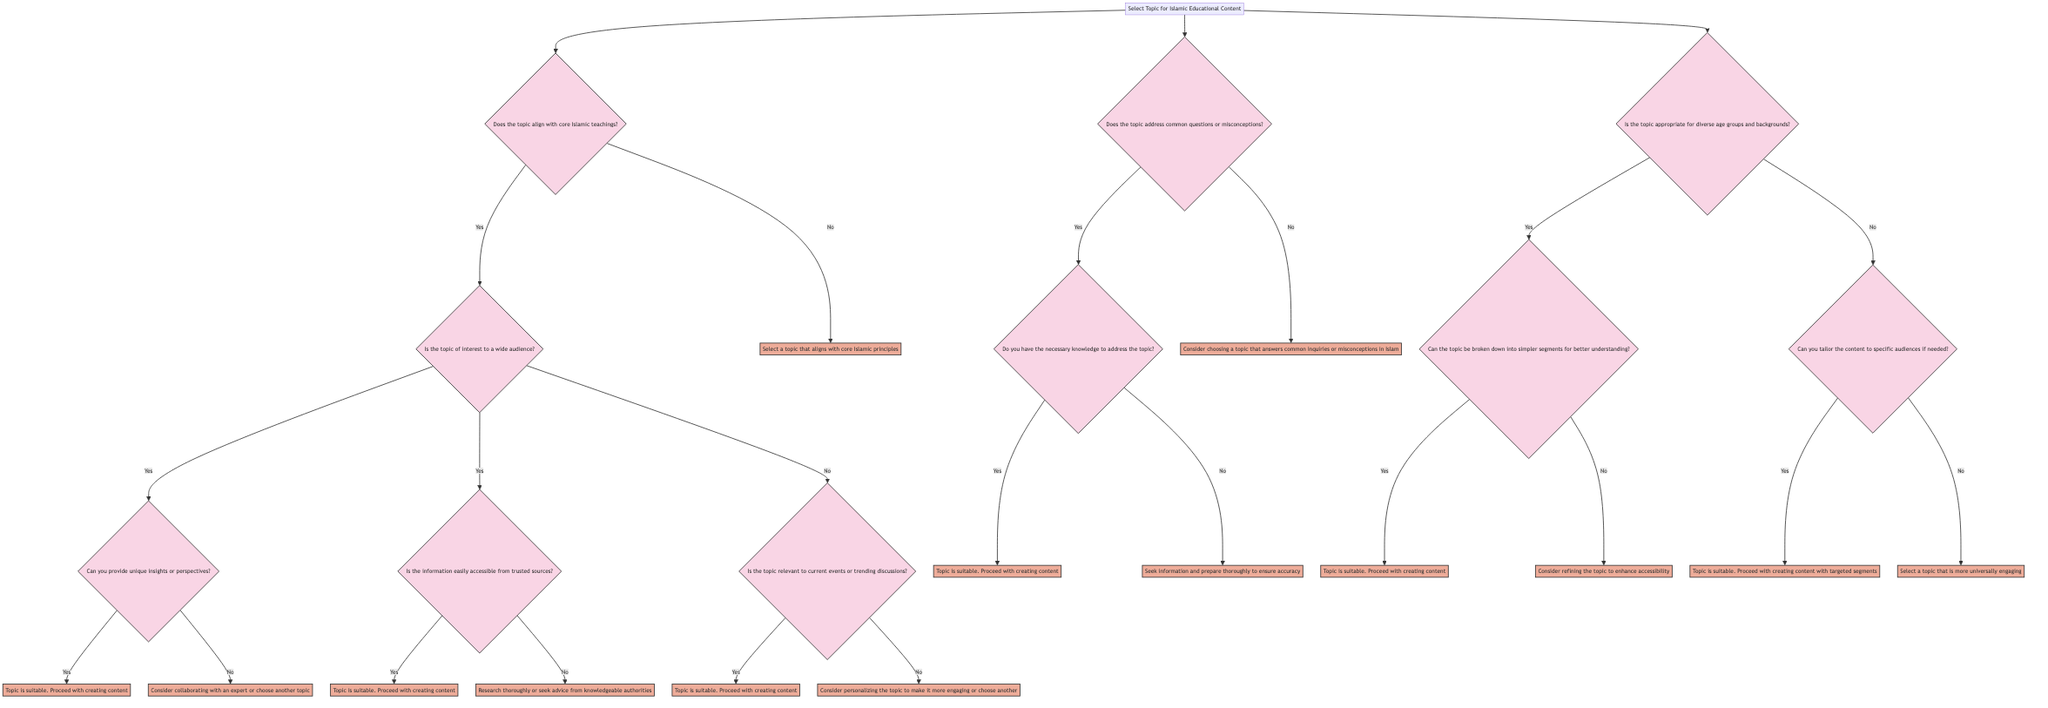What is the first question in the diagram? The first question in the diagram asks, "Does the topic align with core Islamic teachings?" which is the starting point for selecting a topic for Islamic educational content.
Answer: Does the topic align with core Islamic teachings? How many actions are in the diagram? By reviewing the diagram's end points, we can count the actions at the various paths, totaling 8 unique actions that suggest what to do next.
Answer: 8 What question follows "Is the topic of interest to a wide audience?" The question that follows is "Can you provide unique insights or perspectives?" as it branches from the affirmative answer to the previous question about audience interest.
Answer: Can you provide unique insights or perspectives? What should be done if the topic does not align with core Islamic teachings? If the topic does not align with core Islamic teachings, the action is to "Select a topic that aligns with core Islamic principles," indicating a need for relevance to the core teachings.
Answer: Select a topic that aligns with core Islamic principles What is the action if the topic is suitable and you can break it down? If the topic is suitable and can be broken down into simpler segments for better understanding, the action is to "Proceed with creating content."
Answer: Proceed with creating content What does the pathway look like if the topic does not address common questions? If the topic does not address common inquiries or misconceptions in Islam, the recommended action is to "Consider choosing a topic that answers common inquiries or misconceptions in Islam."
Answer: Consider choosing a topic that answers common inquiries or misconceptions in Islam What is the second major decision point in the diagram? The second major decision point in the diagram is "Does the topic address common questions or misconceptions?" which helps refine the selection of suitable topics.
Answer: Does the topic address common questions or misconceptions? What happens if the information is not easily accessible from trusted sources? If the information is not easily accessible from trusted sources, the action would be to "Research thoroughly or seek advice from knowledgeable authorities," which implies a need for due diligence.
Answer: Research thoroughly or seek advice from knowledgeable authorities 